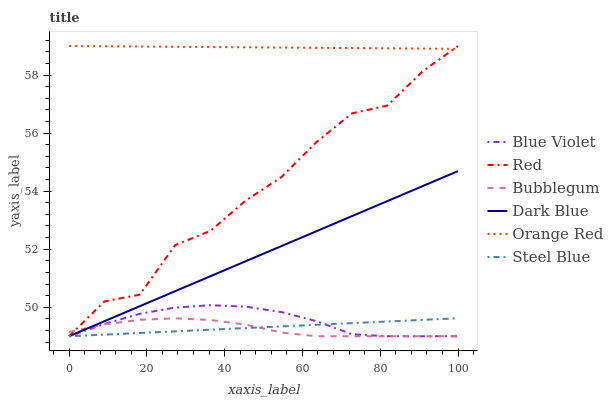Does Bubblegum have the minimum area under the curve?
Answer yes or no. Yes. Does Orange Red have the maximum area under the curve?
Answer yes or no. Yes. Does Dark Blue have the minimum area under the curve?
Answer yes or no. No. Does Dark Blue have the maximum area under the curve?
Answer yes or no. No. Is Steel Blue the smoothest?
Answer yes or no. Yes. Is Red the roughest?
Answer yes or no. Yes. Is Bubblegum the smoothest?
Answer yes or no. No. Is Bubblegum the roughest?
Answer yes or no. No. Does Steel Blue have the lowest value?
Answer yes or no. Yes. Does Orange Red have the lowest value?
Answer yes or no. No. Does Red have the highest value?
Answer yes or no. Yes. Does Dark Blue have the highest value?
Answer yes or no. No. Is Blue Violet less than Orange Red?
Answer yes or no. Yes. Is Orange Red greater than Blue Violet?
Answer yes or no. Yes. Does Red intersect Orange Red?
Answer yes or no. Yes. Is Red less than Orange Red?
Answer yes or no. No. Is Red greater than Orange Red?
Answer yes or no. No. Does Blue Violet intersect Orange Red?
Answer yes or no. No. 